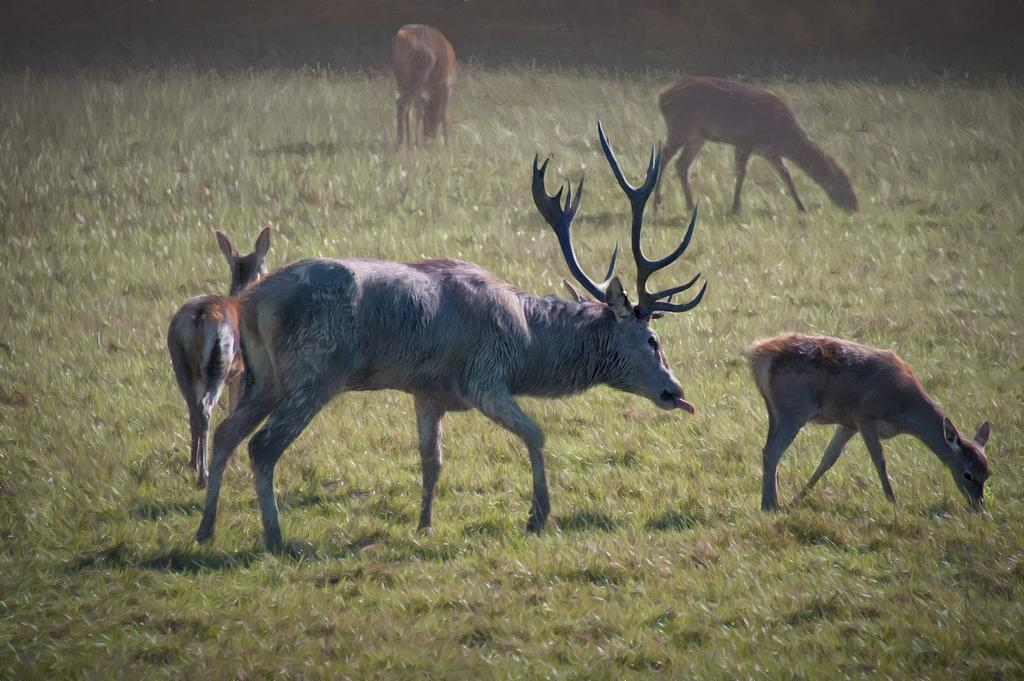What types of living organisms are present in the image? There are animals in the image. What is the position of the animals in the image? The animals are standing on the ground. What type of vegetation can be seen in the background of the image? There is grass visible in the background of the image. How many oranges are being carried by the animals in the image? There are no oranges present in the image. Can you tell me what type of work the animals are doing in the image? The image does not depict the animals performing any work or tasks. 